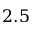<formula> <loc_0><loc_0><loc_500><loc_500>2 . 5</formula> 